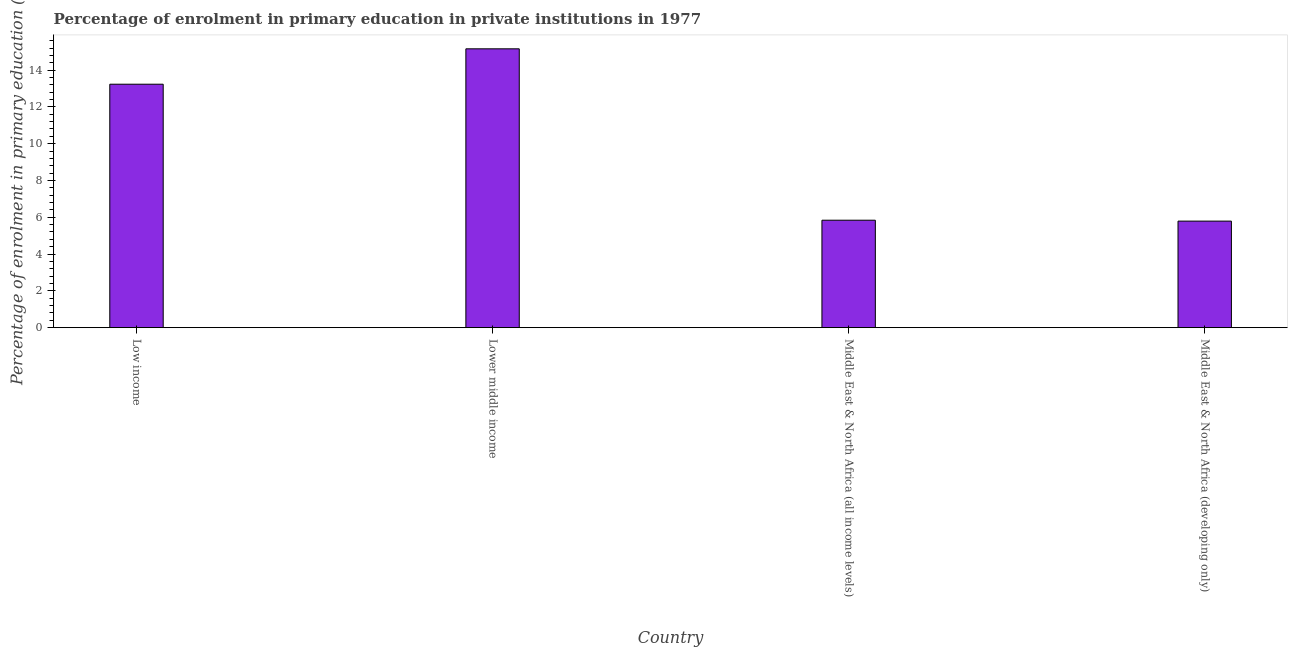Does the graph contain any zero values?
Make the answer very short. No. What is the title of the graph?
Offer a very short reply. Percentage of enrolment in primary education in private institutions in 1977. What is the label or title of the Y-axis?
Keep it short and to the point. Percentage of enrolment in primary education (%). What is the enrolment percentage in primary education in Low income?
Ensure brevity in your answer.  13.23. Across all countries, what is the maximum enrolment percentage in primary education?
Make the answer very short. 15.16. Across all countries, what is the minimum enrolment percentage in primary education?
Your answer should be very brief. 5.79. In which country was the enrolment percentage in primary education maximum?
Give a very brief answer. Lower middle income. In which country was the enrolment percentage in primary education minimum?
Keep it short and to the point. Middle East & North Africa (developing only). What is the sum of the enrolment percentage in primary education?
Keep it short and to the point. 40.02. What is the difference between the enrolment percentage in primary education in Middle East & North Africa (all income levels) and Middle East & North Africa (developing only)?
Keep it short and to the point. 0.05. What is the average enrolment percentage in primary education per country?
Your response must be concise. 10.01. What is the median enrolment percentage in primary education?
Ensure brevity in your answer.  9.54. In how many countries, is the enrolment percentage in primary education greater than 8.4 %?
Your answer should be very brief. 2. What is the ratio of the enrolment percentage in primary education in Lower middle income to that in Middle East & North Africa (developing only)?
Provide a succinct answer. 2.62. What is the difference between the highest and the second highest enrolment percentage in primary education?
Keep it short and to the point. 1.92. Is the sum of the enrolment percentage in primary education in Low income and Middle East & North Africa (developing only) greater than the maximum enrolment percentage in primary education across all countries?
Ensure brevity in your answer.  Yes. What is the difference between the highest and the lowest enrolment percentage in primary education?
Offer a very short reply. 9.37. In how many countries, is the enrolment percentage in primary education greater than the average enrolment percentage in primary education taken over all countries?
Ensure brevity in your answer.  2. How many countries are there in the graph?
Keep it short and to the point. 4. What is the difference between two consecutive major ticks on the Y-axis?
Your answer should be very brief. 2. What is the Percentage of enrolment in primary education (%) of Low income?
Provide a succinct answer. 13.23. What is the Percentage of enrolment in primary education (%) in Lower middle income?
Your answer should be compact. 15.16. What is the Percentage of enrolment in primary education (%) in Middle East & North Africa (all income levels)?
Offer a very short reply. 5.84. What is the Percentage of enrolment in primary education (%) of Middle East & North Africa (developing only)?
Make the answer very short. 5.79. What is the difference between the Percentage of enrolment in primary education (%) in Low income and Lower middle income?
Ensure brevity in your answer.  -1.92. What is the difference between the Percentage of enrolment in primary education (%) in Low income and Middle East & North Africa (all income levels)?
Your response must be concise. 7.39. What is the difference between the Percentage of enrolment in primary education (%) in Low income and Middle East & North Africa (developing only)?
Provide a short and direct response. 7.44. What is the difference between the Percentage of enrolment in primary education (%) in Lower middle income and Middle East & North Africa (all income levels)?
Offer a terse response. 9.32. What is the difference between the Percentage of enrolment in primary education (%) in Lower middle income and Middle East & North Africa (developing only)?
Keep it short and to the point. 9.37. What is the difference between the Percentage of enrolment in primary education (%) in Middle East & North Africa (all income levels) and Middle East & North Africa (developing only)?
Ensure brevity in your answer.  0.05. What is the ratio of the Percentage of enrolment in primary education (%) in Low income to that in Lower middle income?
Your answer should be very brief. 0.87. What is the ratio of the Percentage of enrolment in primary education (%) in Low income to that in Middle East & North Africa (all income levels)?
Your response must be concise. 2.27. What is the ratio of the Percentage of enrolment in primary education (%) in Low income to that in Middle East & North Africa (developing only)?
Your answer should be very brief. 2.29. What is the ratio of the Percentage of enrolment in primary education (%) in Lower middle income to that in Middle East & North Africa (all income levels)?
Your answer should be compact. 2.6. What is the ratio of the Percentage of enrolment in primary education (%) in Lower middle income to that in Middle East & North Africa (developing only)?
Your answer should be compact. 2.62. What is the ratio of the Percentage of enrolment in primary education (%) in Middle East & North Africa (all income levels) to that in Middle East & North Africa (developing only)?
Ensure brevity in your answer.  1.01. 